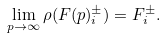Convert formula to latex. <formula><loc_0><loc_0><loc_500><loc_500>\lim _ { p \rightarrow \infty } \rho ( F ( p ) _ { i } ^ { \pm } ) = F _ { i } ^ { \pm } .</formula> 